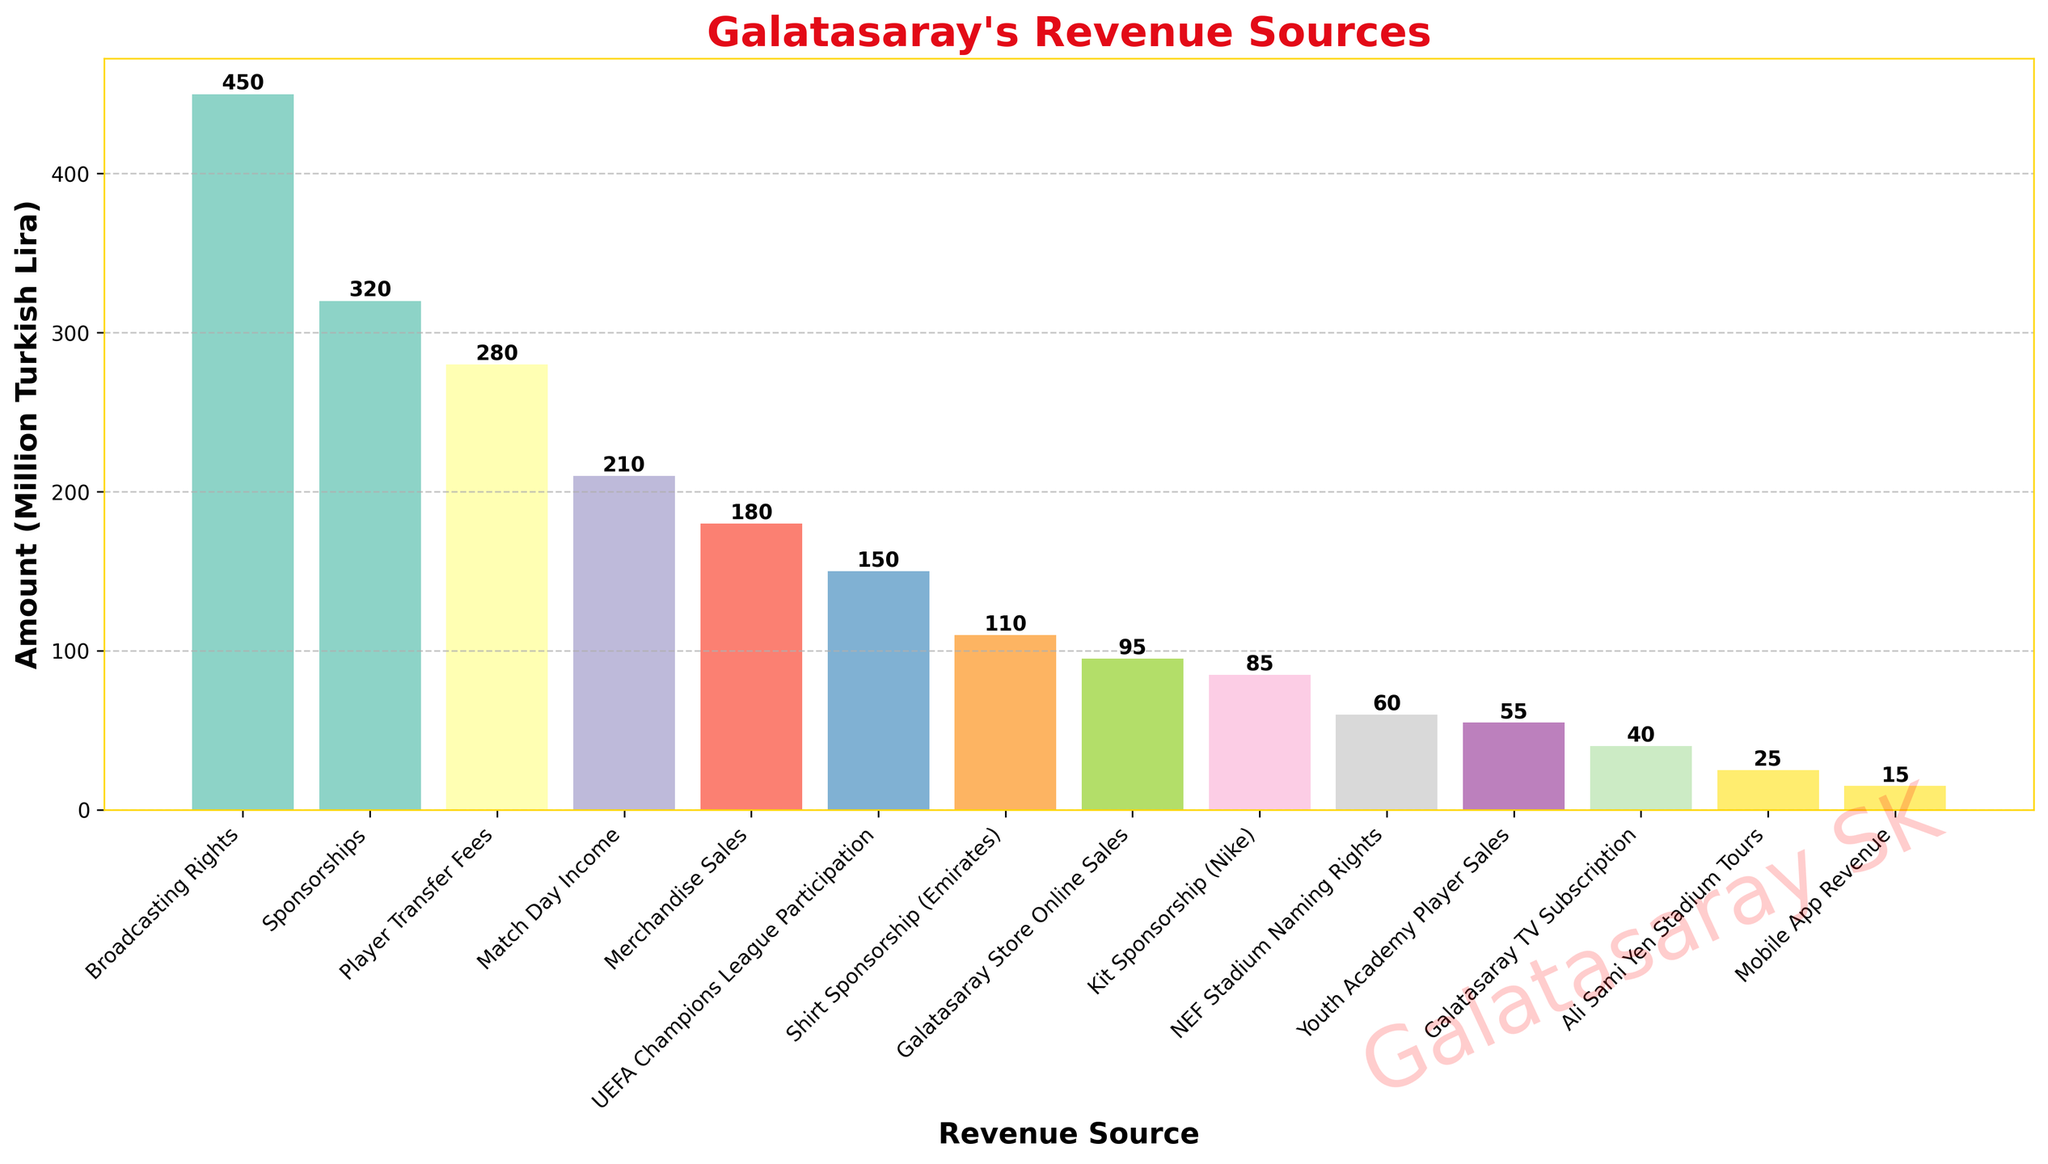Which revenue source generated the highest income for Galatasaray? The bar representing "Broadcasting Rights" is the tallest, indicating it has the highest value among all revenue sources in the figure.
Answer: Broadcasting Rights What is the combined revenue from Ticket Sales, Merchandise Sales, and Mobile App Revenue? The values for "Match Day Income", "Merchandise Sales", and "Mobile App Revenue" are 210, 180, and 15 million Turkish Lira respectively. Adding them together gives 210 + 180 + 15 = 405 million Turkish Lira.
Answer: 405 million Turkish Lira How much more revenue was generated from Shirt Sponsorship (Emirates) compared to Kit Sponsorship (Nike)? The values for "Shirt Sponsorship (Emirates)" and "Kit Sponsorship (Nike)" are 110 and 85 million Turkish Lira respectively. The difference is 110 - 85 = 25 million Turkish Lira.
Answer: 25 million Turkish Lira Which revenue sources have amounts less than 100 million Turkish Lira? The bars for "Ali Sami Yen Stadium Tours", "Galatasaray Store Online Sales", "NEF Stadium Naming Rights", "Kit Sponsorship (Nike)", "Galatasaray TV Subscription", "Mobile App Revenue", and "Youth Academy Player Sales" are all lower than the 100 million Turkish Lira mark.
Answer: Ali Sami Yen Stadium Tours, Galatasaray Store Online Sales, NEF Stadium Naming Rights, Kit Sponsorship (Nike), Galatasaray TV Subscription, Mobile App Revenue, Youth Academy Player Sales What is the total revenue generated from all listed sources? Summing up all the values: 210 + 450 + 320 + 180 + 280 + 150 + 25 + 95 + 60 + 85 + 110 + 40 + 15 + 55 = 2075 million Turkish Lira.
Answer: 2075 million Turkish Lira Which source contributed more to Galatasaray's revenue: UEFA Champions League Participation or Player Transfer Fees? The values for "UEFA Champions League Participation" and "Player Transfer Fees" are 150 and 280 million Turkish Lira respectively. Comparing these, "Player Transfer Fees" is higher.
Answer: Player Transfer Fees Which revenue source is visually represented by the bar with the lowest height in the figure? The shortest bar corresponds to "Mobile App Revenue" which has the smallest value among all revenue sources listed.
Answer: Mobile App Revenue How does the revenue from "Match Day Income" compare to "Merchandise Sales"? The revenue from "Match Day Income" is 210 million Turkish Lira, while "Merchandise Sales" has 180 million Turkish Lira. Match Day Income is higher by 210 - 180 = 30 million Turkish Lira.
Answer: Match Day Income is higher by 30 million Turkish Lira 